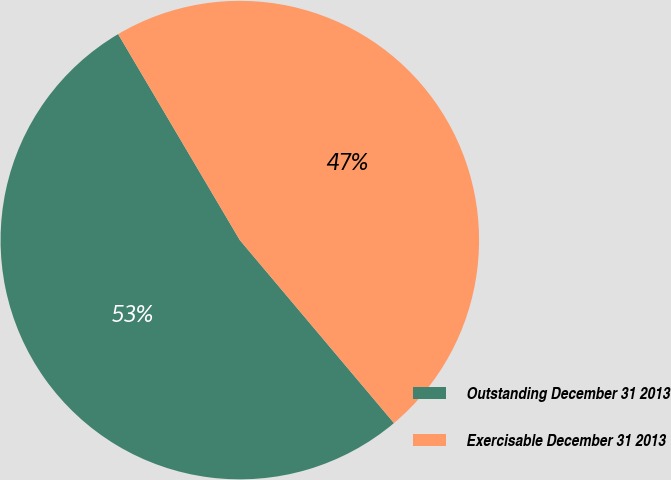Convert chart to OTSL. <chart><loc_0><loc_0><loc_500><loc_500><pie_chart><fcel>Outstanding December 31 2013<fcel>Exercisable December 31 2013<nl><fcel>52.65%<fcel>47.35%<nl></chart> 